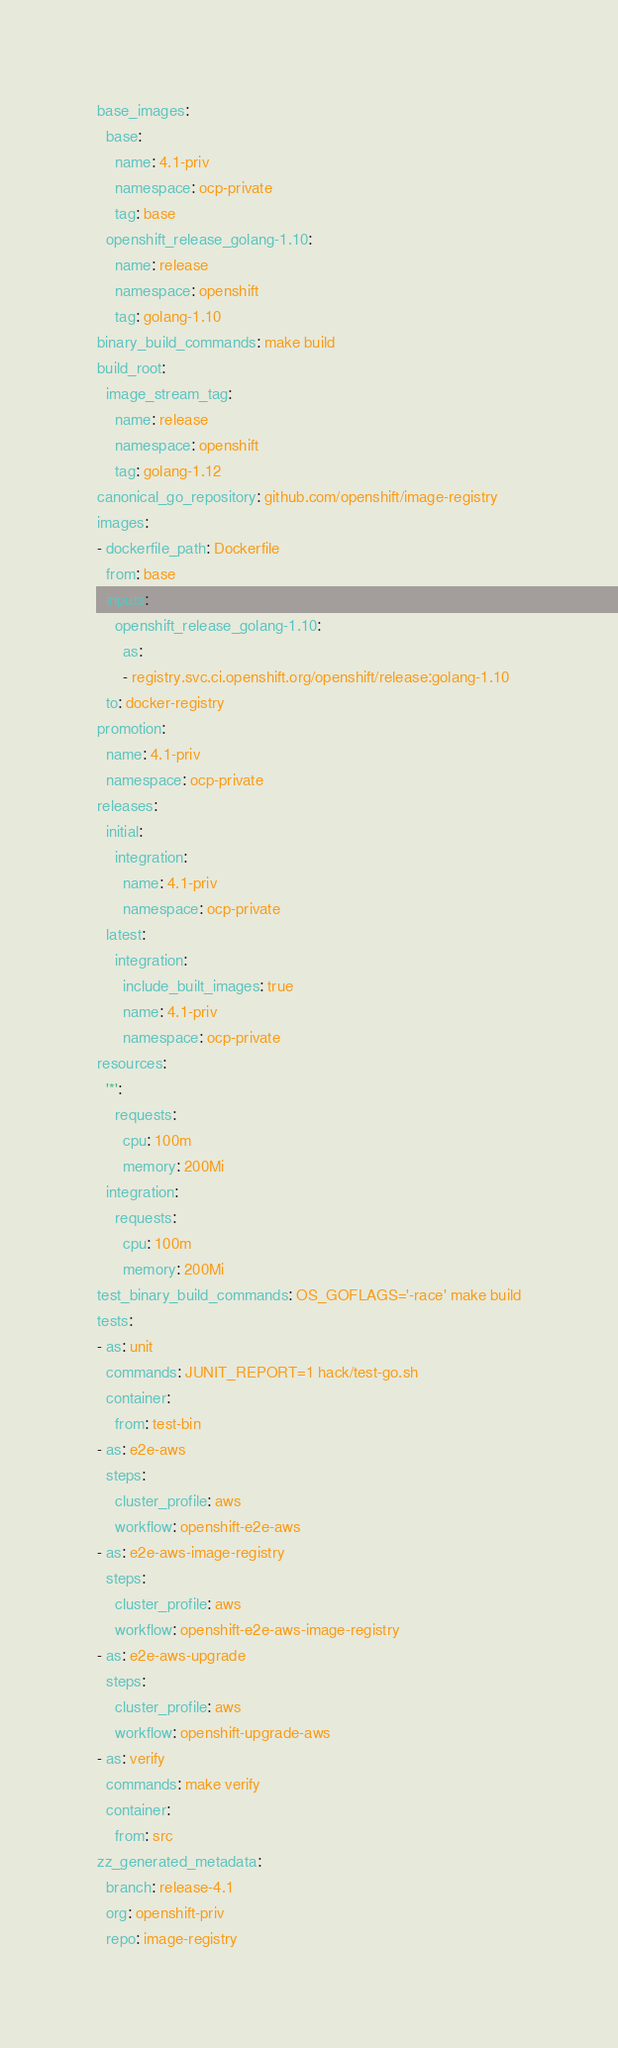<code> <loc_0><loc_0><loc_500><loc_500><_YAML_>base_images:
  base:
    name: 4.1-priv
    namespace: ocp-private
    tag: base
  openshift_release_golang-1.10:
    name: release
    namespace: openshift
    tag: golang-1.10
binary_build_commands: make build
build_root:
  image_stream_tag:
    name: release
    namespace: openshift
    tag: golang-1.12
canonical_go_repository: github.com/openshift/image-registry
images:
- dockerfile_path: Dockerfile
  from: base
  inputs:
    openshift_release_golang-1.10:
      as:
      - registry.svc.ci.openshift.org/openshift/release:golang-1.10
  to: docker-registry
promotion:
  name: 4.1-priv
  namespace: ocp-private
releases:
  initial:
    integration:
      name: 4.1-priv
      namespace: ocp-private
  latest:
    integration:
      include_built_images: true
      name: 4.1-priv
      namespace: ocp-private
resources:
  '*':
    requests:
      cpu: 100m
      memory: 200Mi
  integration:
    requests:
      cpu: 100m
      memory: 200Mi
test_binary_build_commands: OS_GOFLAGS='-race' make build
tests:
- as: unit
  commands: JUNIT_REPORT=1 hack/test-go.sh
  container:
    from: test-bin
- as: e2e-aws
  steps:
    cluster_profile: aws
    workflow: openshift-e2e-aws
- as: e2e-aws-image-registry
  steps:
    cluster_profile: aws
    workflow: openshift-e2e-aws-image-registry
- as: e2e-aws-upgrade
  steps:
    cluster_profile: aws
    workflow: openshift-upgrade-aws
- as: verify
  commands: make verify
  container:
    from: src
zz_generated_metadata:
  branch: release-4.1
  org: openshift-priv
  repo: image-registry
</code> 